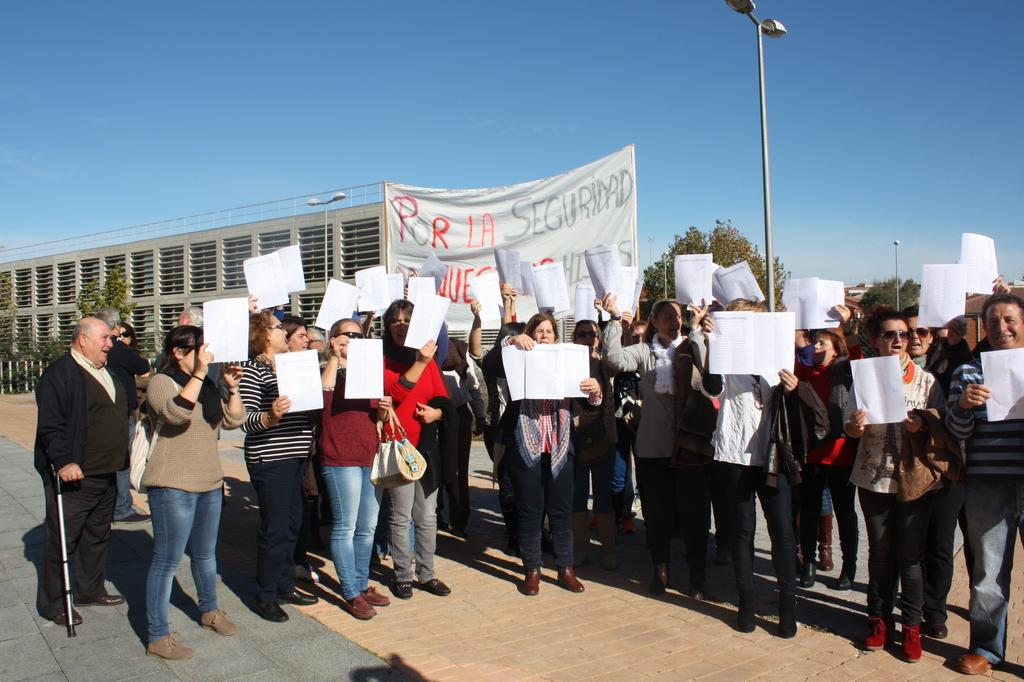What are the people in the image doing? The people in the image are standing and holding placards. What can be seen in the background of the image? There are trees, buildings, and lamp posts in the background of the image. What type of crime is being committed in the image? There is no indication of any crime being committed in the image; the people are holding placards, which suggests a peaceful demonstration or gathering. 